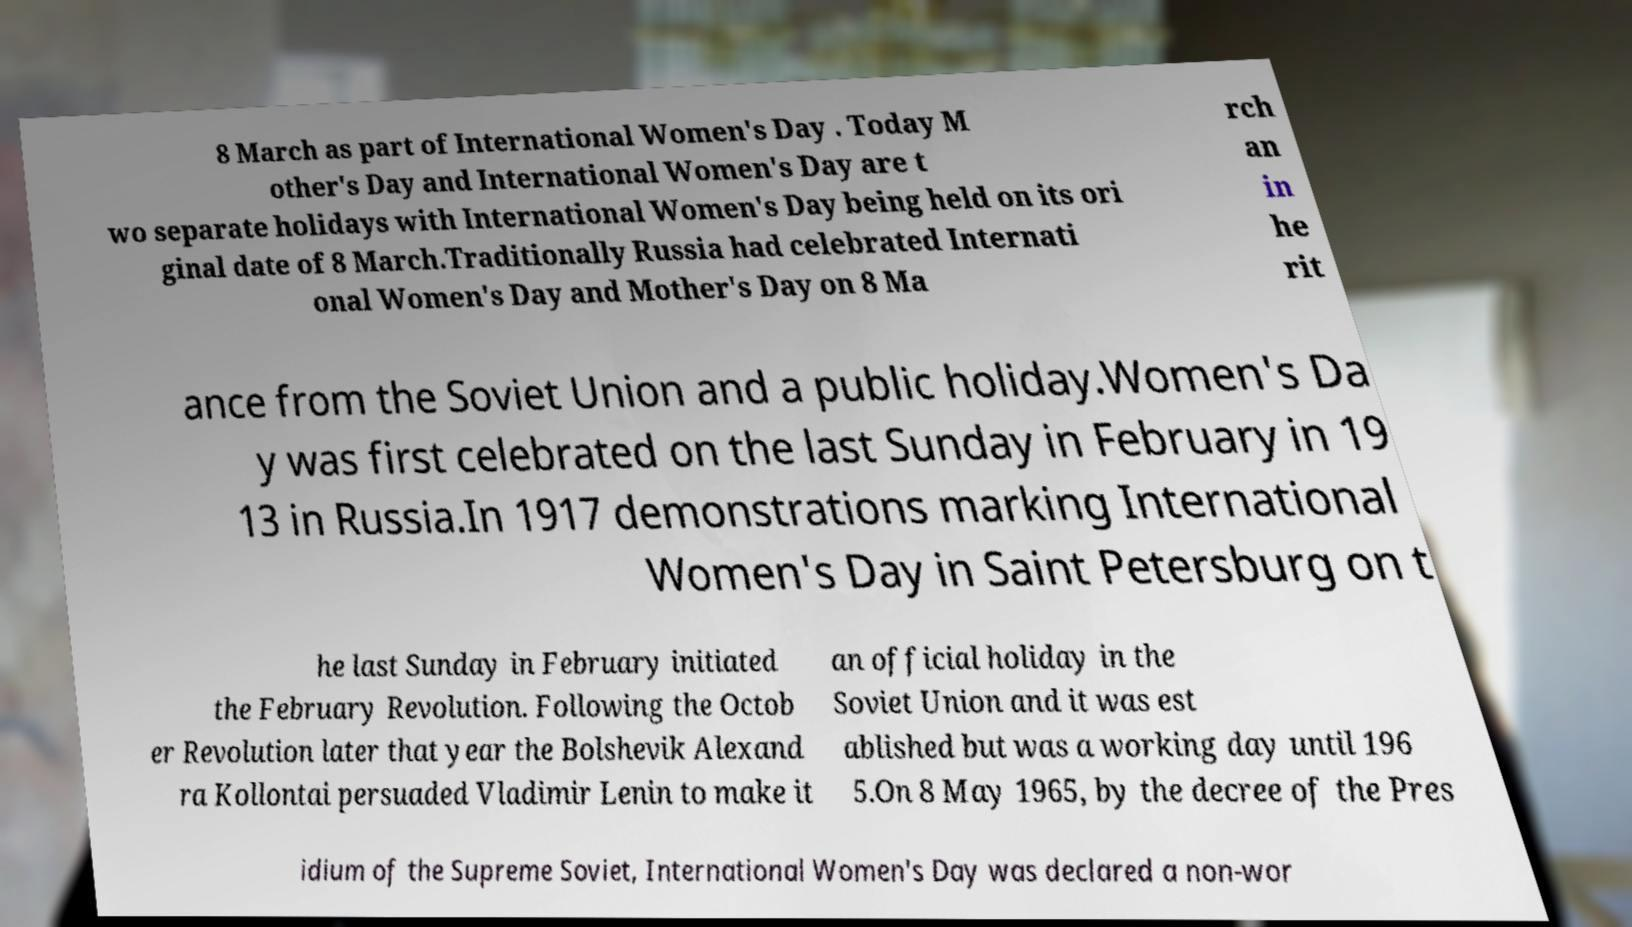Please read and relay the text visible in this image. What does it say? 8 March as part of International Women's Day . Today M other's Day and International Women's Day are t wo separate holidays with International Women's Day being held on its ori ginal date of 8 March.Traditionally Russia had celebrated Internati onal Women's Day and Mother's Day on 8 Ma rch an in he rit ance from the Soviet Union and a public holiday.Women's Da y was first celebrated on the last Sunday in February in 19 13 in Russia.In 1917 demonstrations marking International Women's Day in Saint Petersburg on t he last Sunday in February initiated the February Revolution. Following the Octob er Revolution later that year the Bolshevik Alexand ra Kollontai persuaded Vladimir Lenin to make it an official holiday in the Soviet Union and it was est ablished but was a working day until 196 5.On 8 May 1965, by the decree of the Pres idium of the Supreme Soviet, International Women's Day was declared a non-wor 